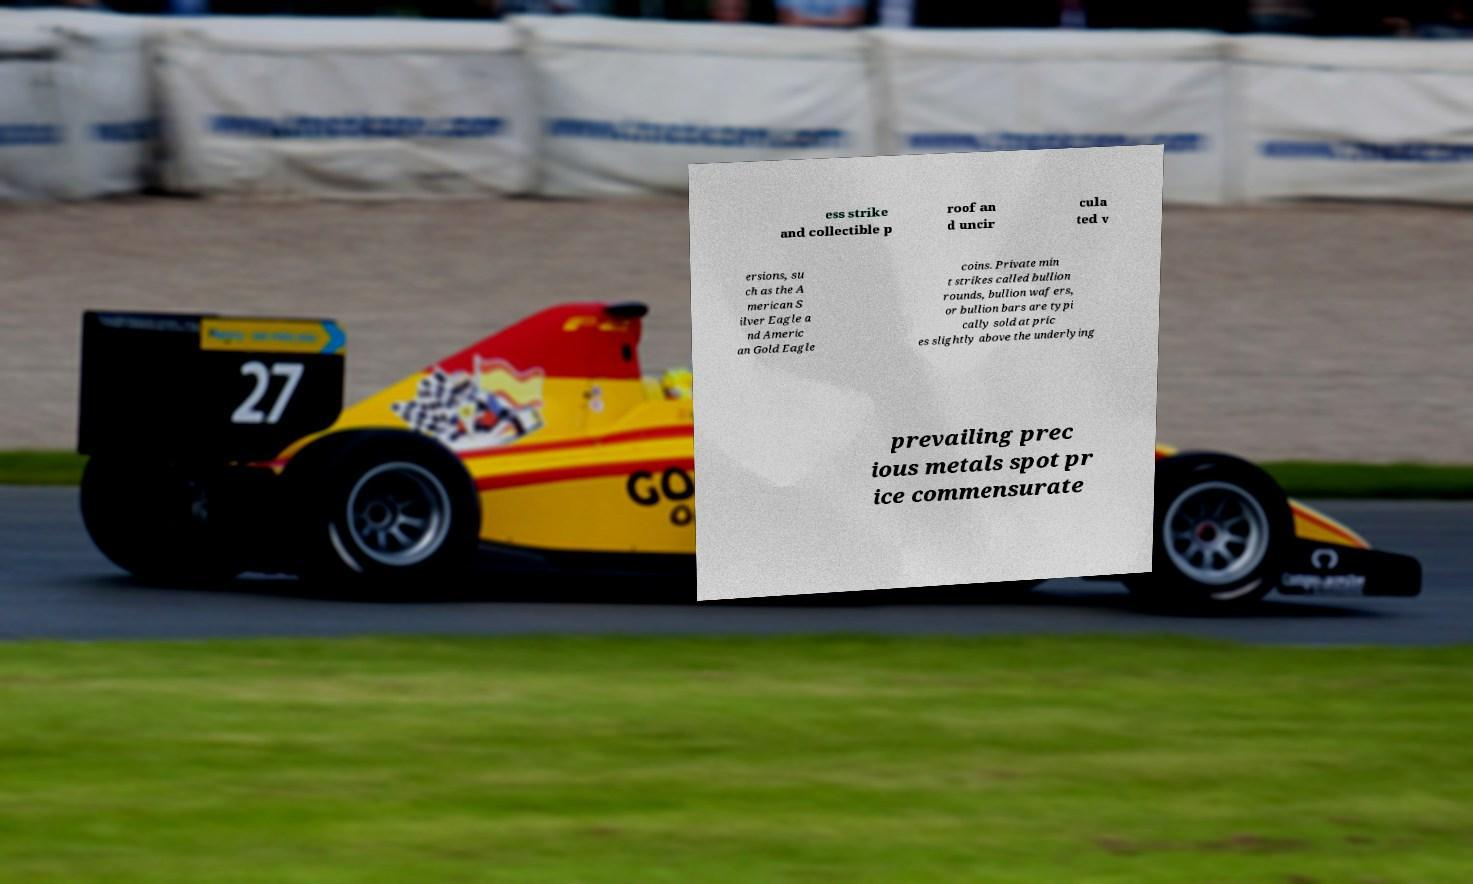Please identify and transcribe the text found in this image. ess strike and collectible p roof an d uncir cula ted v ersions, su ch as the A merican S ilver Eagle a nd Americ an Gold Eagle coins. Private min t strikes called bullion rounds, bullion wafers, or bullion bars are typi cally sold at pric es slightly above the underlying prevailing prec ious metals spot pr ice commensurate 